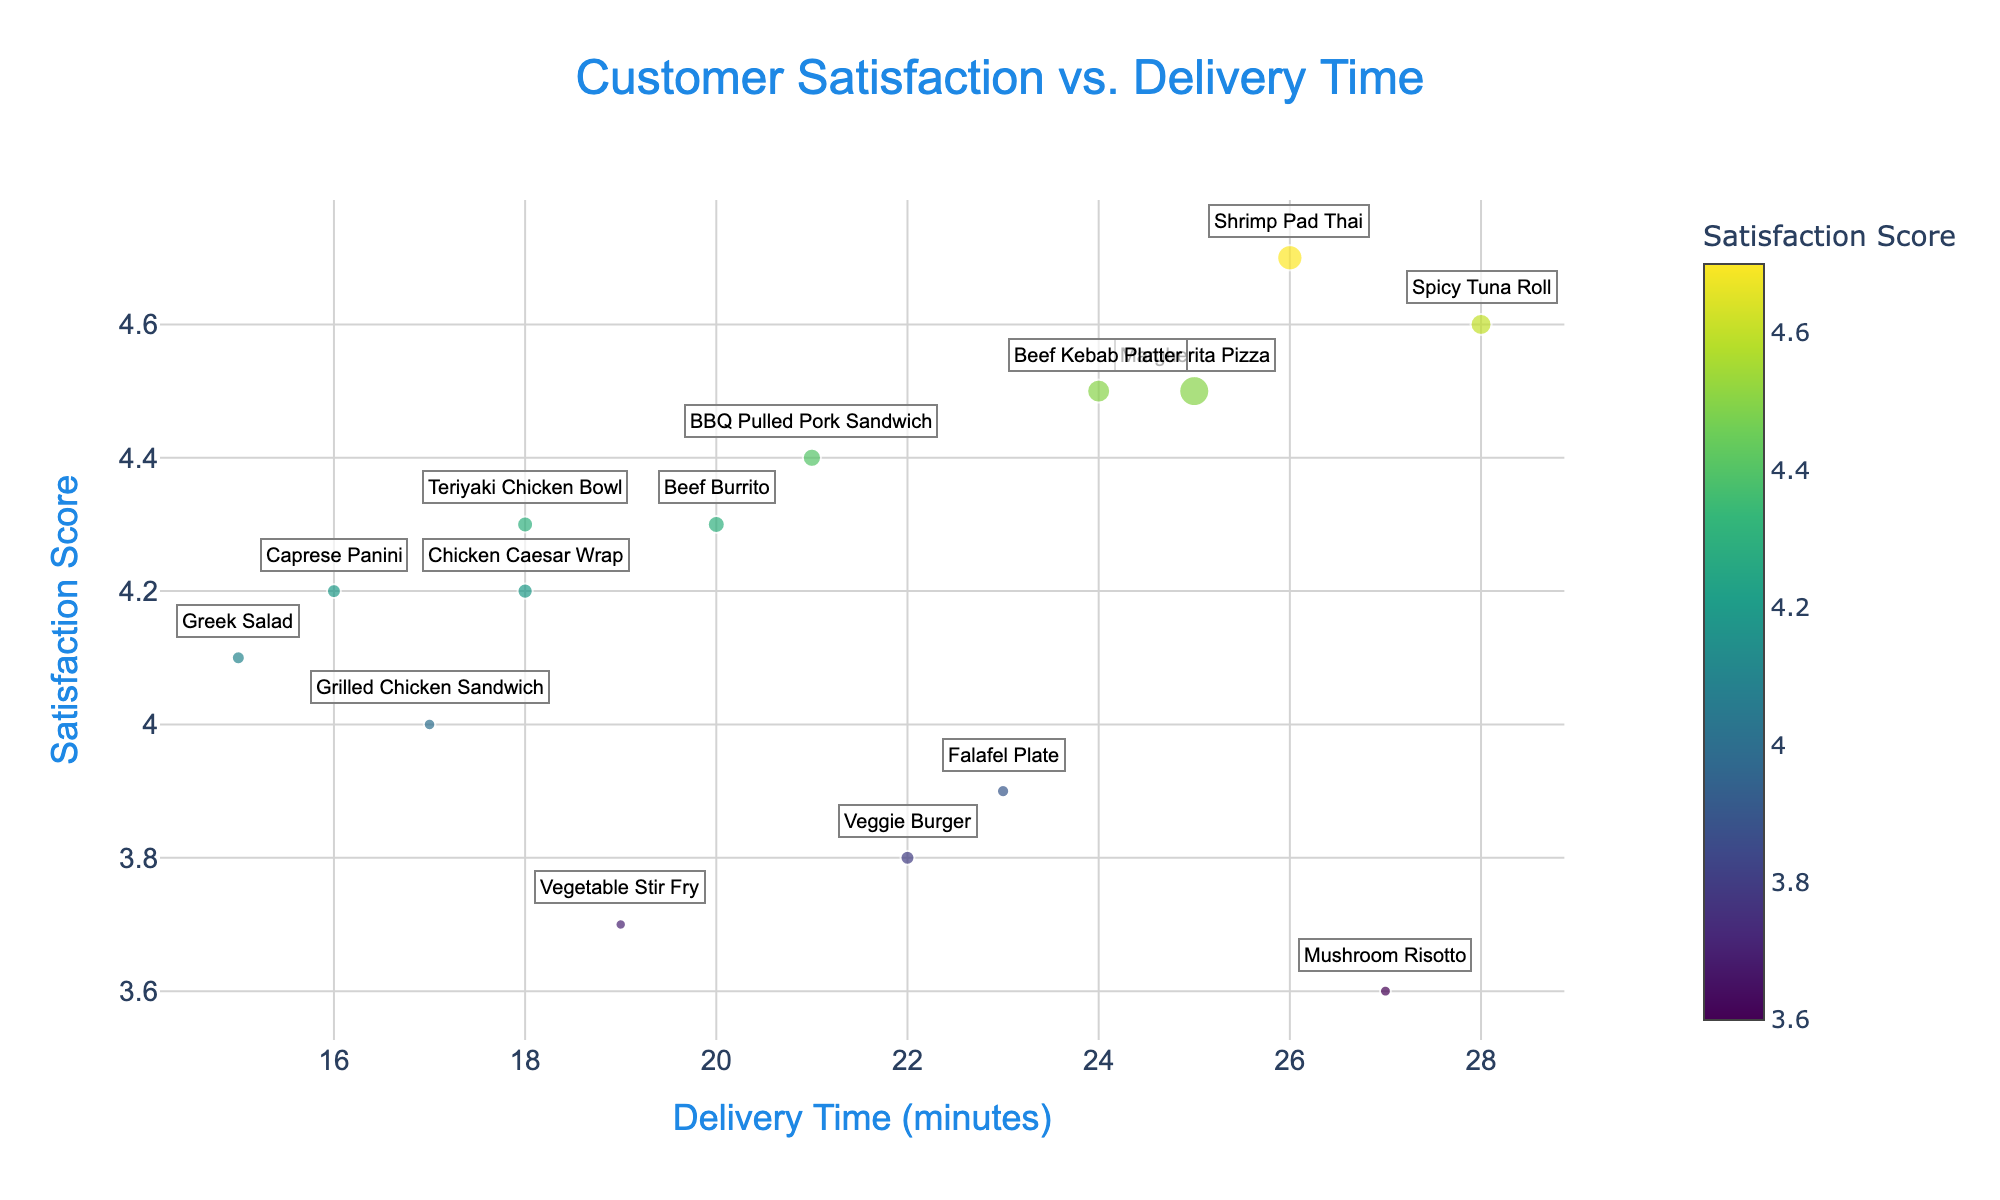Which menu item has the highest satisfaction score? To find the item with the highest satisfaction score, look at the vertical position of the data points. The highest point on the y-axis indicates the highest satisfaction score.
Answer: Shrimp Pad Thai Which menu item has the longest delivery time? The menu item with the longest delivery time will be the farthest to the right on the x-axis.
Answer: Spicy Tuna Roll How does the delivery time of the Margherita Pizza compare to the Greek Salad? To compare their delivery times, look at the horizontal positions of the data points for Margherita Pizza and Greek Salad. The Margherita Pizza is farther to the right, indicating a longer delivery time.
Answer: Margherita Pizza has a longer delivery time than Greek Salad What is the general relationship between delivery time and satisfaction score? Observe the trend of data points. The vertical and horizontal distribution shows that higher satisfaction scores tend to correspond with longer delivery times.
Answer: Longer delivery times generally correspond with higher satisfaction scores Which menu items have a satisfaction score above 4.5? Identify menu items whose data points are above the horizontal line at the satisfaction score of 4.5.
Answer: Spicy Tuna Roll, Shrimp Pad Thai, Beef Kebab Platter, Margherita Pizza Which menu item is the most significant in terms of p-value? The most significant item will have the smallest p-value, which translates to the largest -log10(p-value) value, indicated by the largest bubble size.
Answer: Margherita Pizza What is the difference in delivery time between the Greek Salad and Shrimp Pad Thai? Subtract the delivery time of the Greek Salad from that of the Shrimp Pad Thai: 26 minutes (Shrimp Pad Thai) - 15 minutes (Greek Salad).
Answer: 11 minutes Which menu items are delivered in under 20 minutes and have a satisfaction score above 4.0? Look for data points left of the 20-minute mark on the x-axis and above the 4.0 satisfaction score on the y-axis.
Answer: Greek Salad, Caprese Panini, Grilled Chicken Sandwich, Chicken Caesar Wrap How many menu items have a p-value less than 0.05? Count the data points that are larger in size, representing a -log10(p-value) greater than -log10(0.05).
Answer: 10 